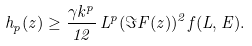<formula> <loc_0><loc_0><loc_500><loc_500>h _ { p } ( z ) \geq \frac { \gamma k ^ { p } } { 1 2 } \, L ^ { p } ( \Im F ( z ) ) ^ { 2 } f ( L , E ) .</formula> 